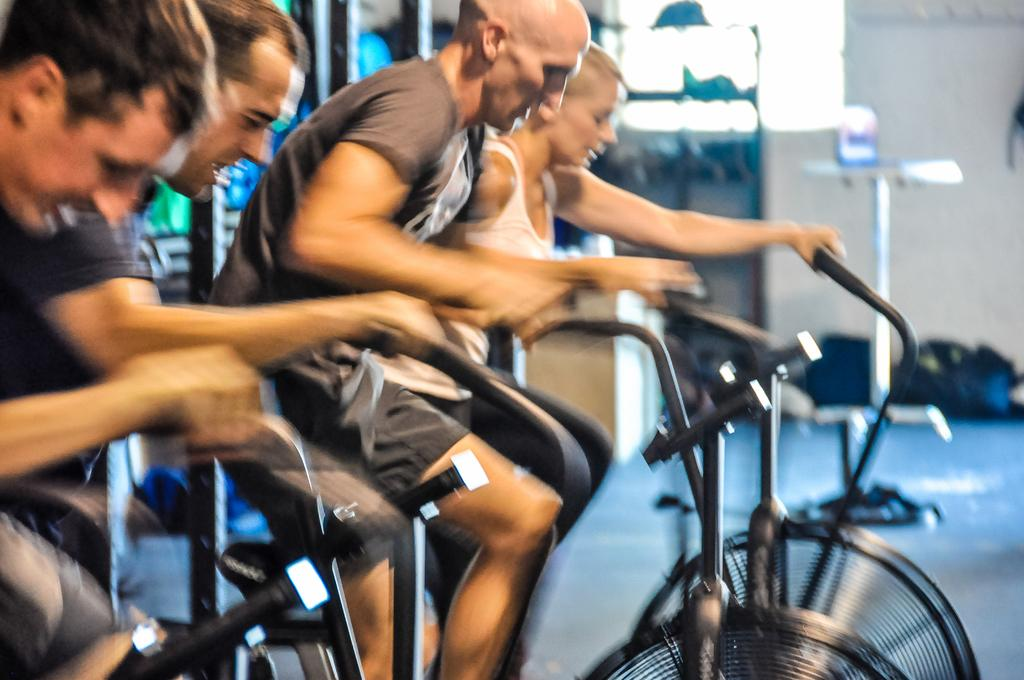What are the people in the image doing? The people in the image are cycling. What can be seen in the background of the image? There is a window, a stand, and bags in the background of the image. What type of bomb can be seen in the image? There is no bomb present in the image. What is inside the jar that is visible in the image? There is no jar present in the image. 